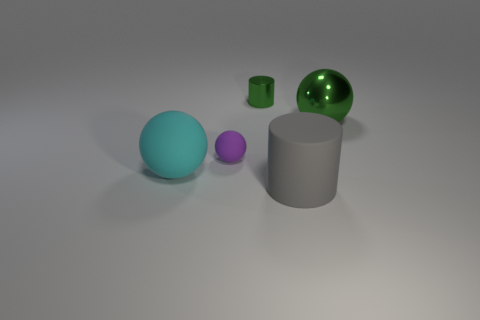What can you tell me about the color palette used in this image? The color palette consists of muted tones. There is a prominent cool blue sphere, a small purple sphere hinting warmth, and a vibrant green on the tiny cylinder. This restrained use of color contrasts with the neutral grays of the other items and the background, resulting in a composition that feels balanced and harmonious but includes spots of color that draw the viewer's eye. 